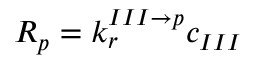Convert formula to latex. <formula><loc_0><loc_0><loc_500><loc_500>R _ { p } = k _ { r } ^ { I I I \rightarrow p } c _ { I I I }</formula> 